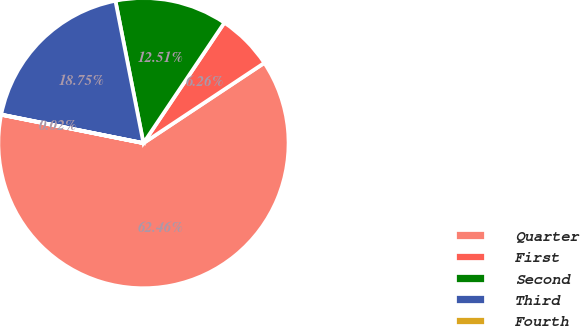<chart> <loc_0><loc_0><loc_500><loc_500><pie_chart><fcel>Quarter<fcel>First<fcel>Second<fcel>Third<fcel>Fourth<nl><fcel>62.46%<fcel>6.26%<fcel>12.51%<fcel>18.75%<fcel>0.02%<nl></chart> 